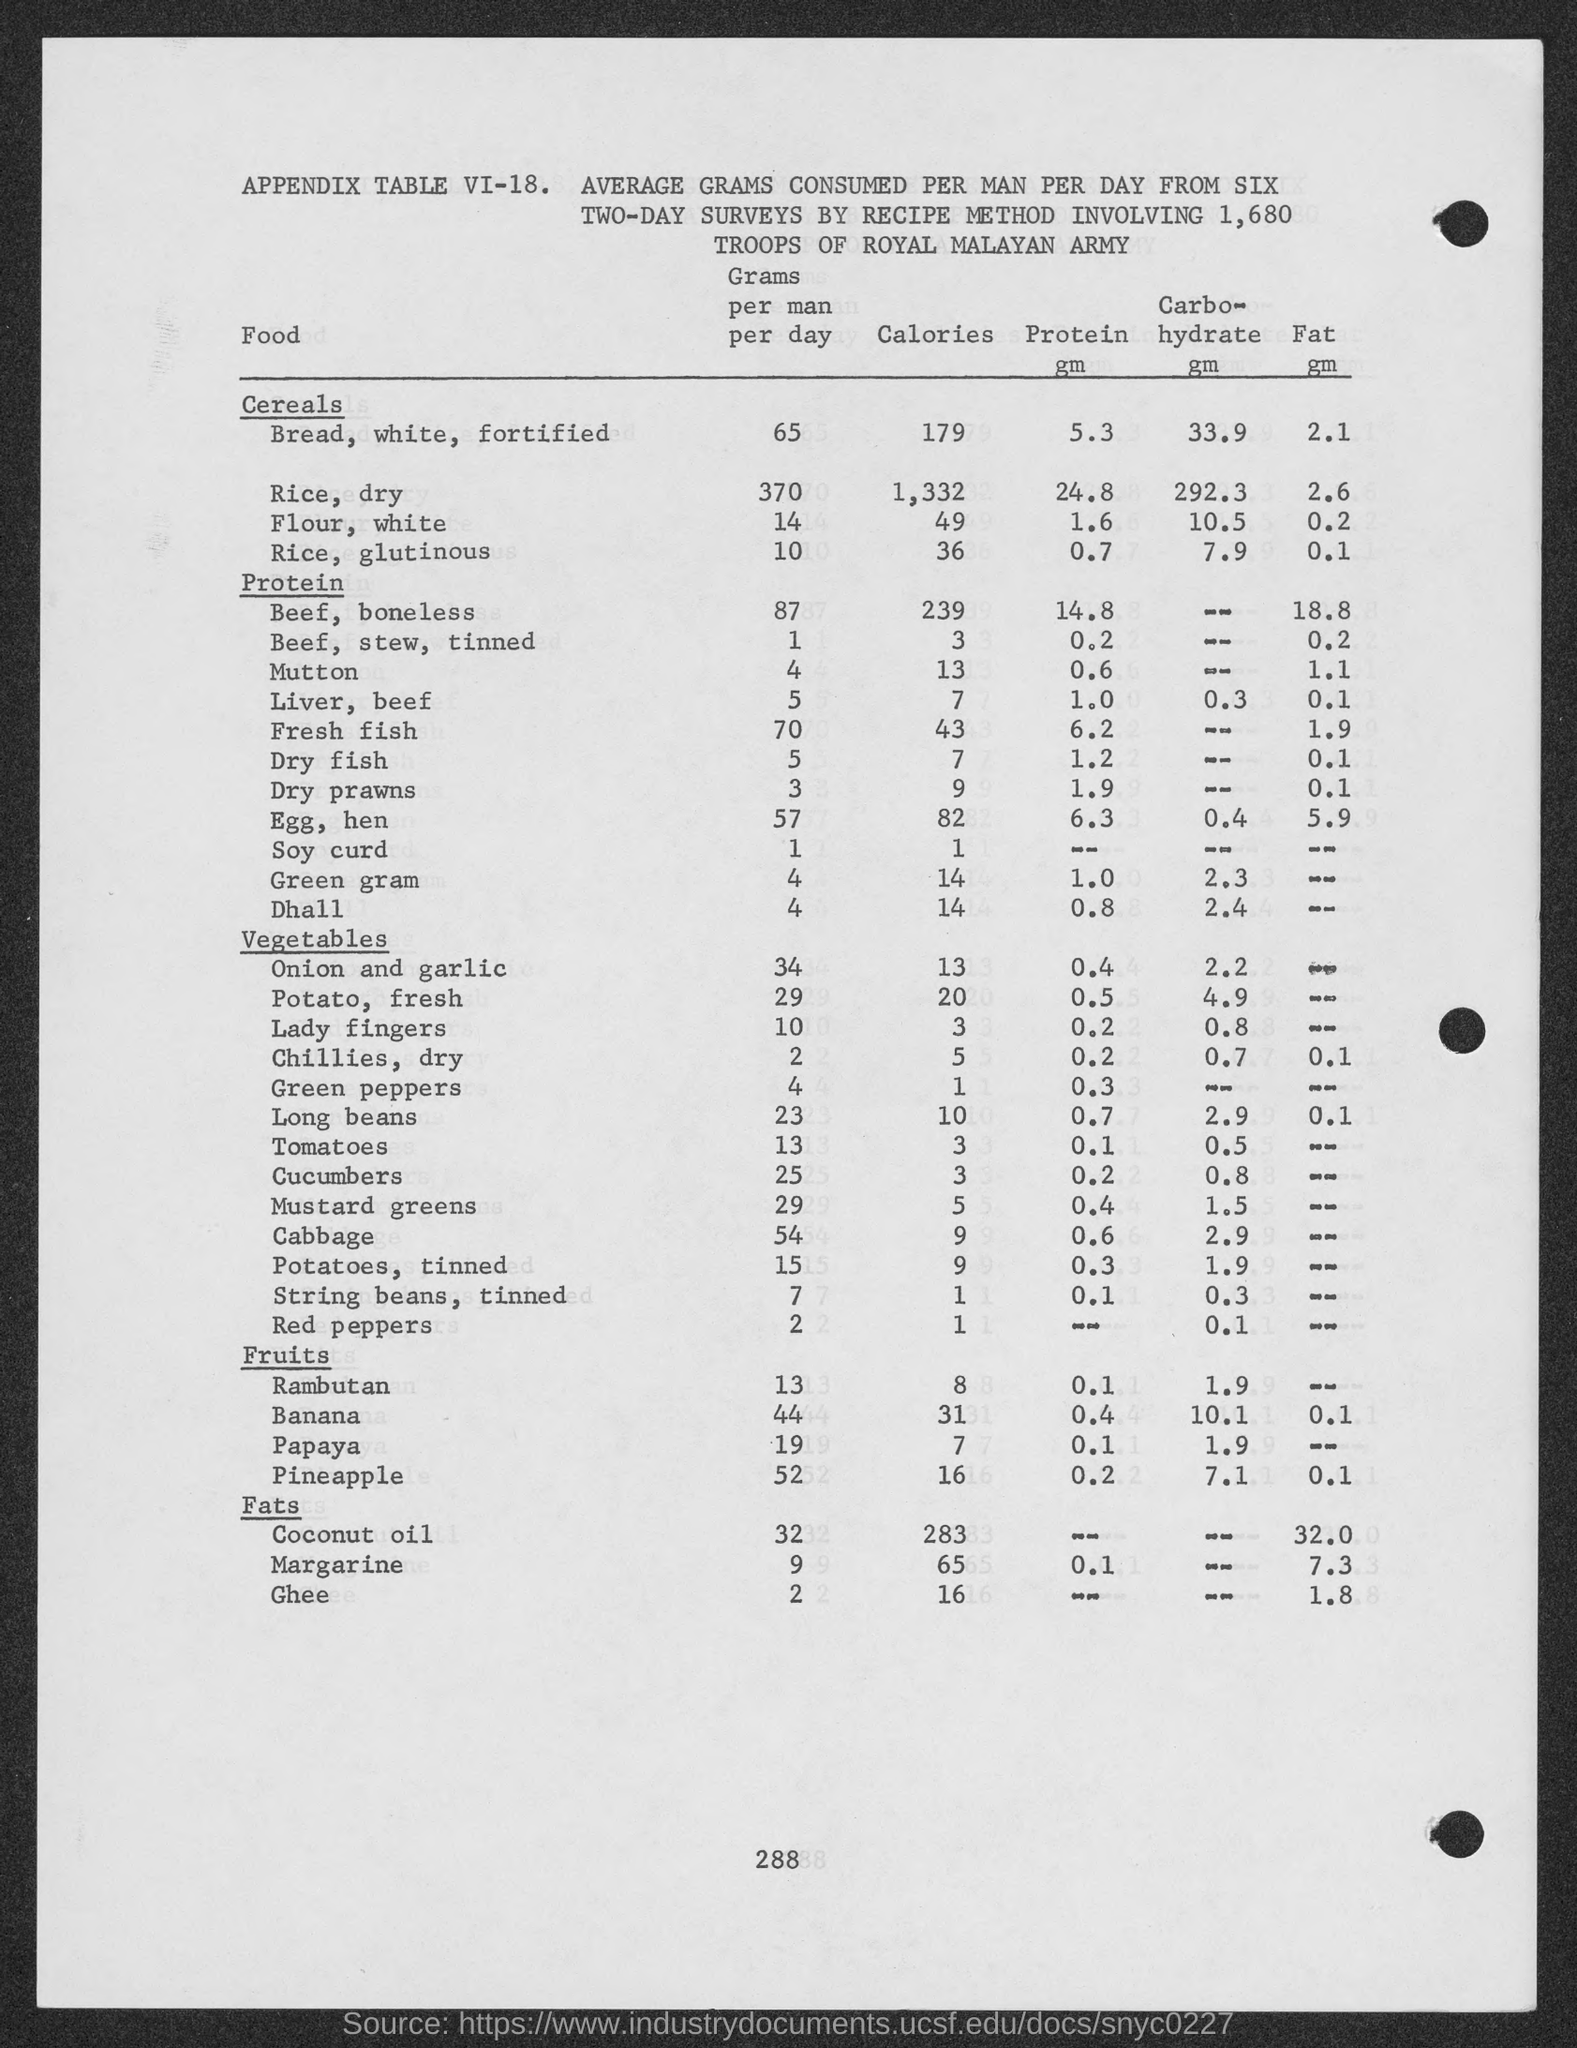What is the calories for Bread, white ,fortified?
Offer a very short reply. 179. What is the calories for Rice, dry?
Provide a succinct answer. 1,332. What is the calories for Flour, white?
Your answer should be very brief. 49. What is the calories for Rice, glutinous?
Your answer should be compact. 36. What is the calories for Beef, boneless?
Your response must be concise. 239. What is the calories for Mutton?
Provide a short and direct response. 13. What is the calories for Liver, beef?
Offer a terse response. 7. What is the calories for Fresh fish?
Your answer should be compact. 43. What is the calories for Dry fish?
Your answer should be very brief. 7. What is the calories for Dry Prawns?
Ensure brevity in your answer.  9. 